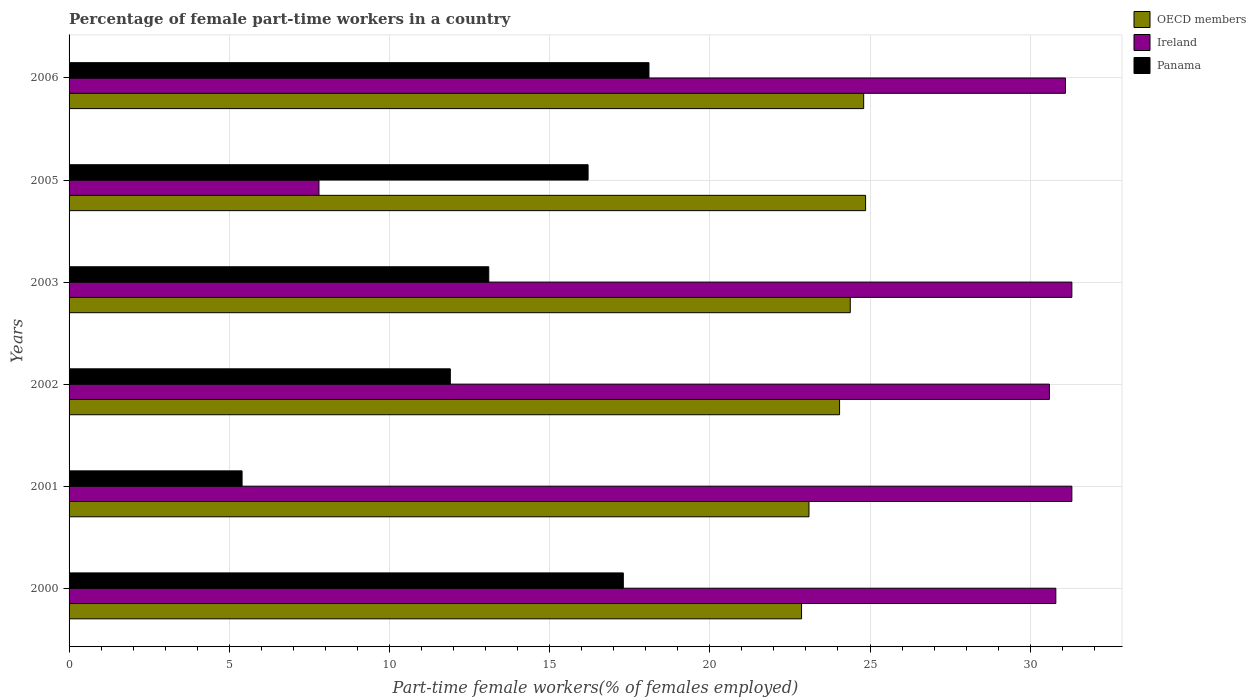How many different coloured bars are there?
Offer a very short reply. 3. Are the number of bars per tick equal to the number of legend labels?
Give a very brief answer. Yes. Are the number of bars on each tick of the Y-axis equal?
Give a very brief answer. Yes. How many bars are there on the 5th tick from the bottom?
Your answer should be compact. 3. In how many cases, is the number of bars for a given year not equal to the number of legend labels?
Offer a very short reply. 0. What is the percentage of female part-time workers in Panama in 2003?
Ensure brevity in your answer.  13.1. Across all years, what is the maximum percentage of female part-time workers in Ireland?
Offer a terse response. 31.3. Across all years, what is the minimum percentage of female part-time workers in Ireland?
Ensure brevity in your answer.  7.8. What is the total percentage of female part-time workers in Ireland in the graph?
Your answer should be compact. 162.9. What is the difference between the percentage of female part-time workers in Panama in 2005 and that in 2006?
Keep it short and to the point. -1.9. What is the difference between the percentage of female part-time workers in Panama in 2005 and the percentage of female part-time workers in OECD members in 2003?
Make the answer very short. -8.18. What is the average percentage of female part-time workers in Panama per year?
Ensure brevity in your answer.  13.67. What is the ratio of the percentage of female part-time workers in Ireland in 2005 to that in 2006?
Keep it short and to the point. 0.25. What is the difference between the highest and the second highest percentage of female part-time workers in OECD members?
Make the answer very short. 0.06. What is the difference between the highest and the lowest percentage of female part-time workers in Panama?
Ensure brevity in your answer.  12.7. What does the 1st bar from the top in 2006 represents?
Offer a terse response. Panama. How many bars are there?
Provide a short and direct response. 18. Are all the bars in the graph horizontal?
Your response must be concise. Yes. Are the values on the major ticks of X-axis written in scientific E-notation?
Offer a terse response. No. Does the graph contain any zero values?
Your response must be concise. No. Does the graph contain grids?
Offer a very short reply. Yes. Where does the legend appear in the graph?
Your response must be concise. Top right. How many legend labels are there?
Keep it short and to the point. 3. How are the legend labels stacked?
Keep it short and to the point. Vertical. What is the title of the graph?
Make the answer very short. Percentage of female part-time workers in a country. Does "Arab World" appear as one of the legend labels in the graph?
Your response must be concise. No. What is the label or title of the X-axis?
Give a very brief answer. Part-time female workers(% of females employed). What is the label or title of the Y-axis?
Give a very brief answer. Years. What is the Part-time female workers(% of females employed) of OECD members in 2000?
Ensure brevity in your answer.  22.86. What is the Part-time female workers(% of females employed) in Ireland in 2000?
Offer a terse response. 30.8. What is the Part-time female workers(% of females employed) of Panama in 2000?
Offer a very short reply. 17.3. What is the Part-time female workers(% of females employed) in OECD members in 2001?
Ensure brevity in your answer.  23.09. What is the Part-time female workers(% of females employed) of Ireland in 2001?
Offer a terse response. 31.3. What is the Part-time female workers(% of females employed) in Panama in 2001?
Give a very brief answer. 5.4. What is the Part-time female workers(% of females employed) in OECD members in 2002?
Offer a terse response. 24.05. What is the Part-time female workers(% of females employed) of Ireland in 2002?
Your answer should be compact. 30.6. What is the Part-time female workers(% of females employed) in Panama in 2002?
Provide a succinct answer. 11.9. What is the Part-time female workers(% of females employed) of OECD members in 2003?
Your answer should be compact. 24.38. What is the Part-time female workers(% of females employed) in Ireland in 2003?
Make the answer very short. 31.3. What is the Part-time female workers(% of females employed) of Panama in 2003?
Make the answer very short. 13.1. What is the Part-time female workers(% of females employed) in OECD members in 2005?
Offer a terse response. 24.86. What is the Part-time female workers(% of females employed) in Ireland in 2005?
Give a very brief answer. 7.8. What is the Part-time female workers(% of females employed) of Panama in 2005?
Your response must be concise. 16.2. What is the Part-time female workers(% of females employed) of OECD members in 2006?
Keep it short and to the point. 24.8. What is the Part-time female workers(% of females employed) of Ireland in 2006?
Give a very brief answer. 31.1. What is the Part-time female workers(% of females employed) in Panama in 2006?
Provide a succinct answer. 18.1. Across all years, what is the maximum Part-time female workers(% of females employed) of OECD members?
Your response must be concise. 24.86. Across all years, what is the maximum Part-time female workers(% of females employed) of Ireland?
Provide a short and direct response. 31.3. Across all years, what is the maximum Part-time female workers(% of females employed) of Panama?
Your response must be concise. 18.1. Across all years, what is the minimum Part-time female workers(% of females employed) in OECD members?
Keep it short and to the point. 22.86. Across all years, what is the minimum Part-time female workers(% of females employed) of Ireland?
Keep it short and to the point. 7.8. Across all years, what is the minimum Part-time female workers(% of females employed) in Panama?
Offer a terse response. 5.4. What is the total Part-time female workers(% of females employed) of OECD members in the graph?
Offer a terse response. 144.06. What is the total Part-time female workers(% of females employed) of Ireland in the graph?
Offer a very short reply. 162.9. What is the total Part-time female workers(% of females employed) in Panama in the graph?
Keep it short and to the point. 82. What is the difference between the Part-time female workers(% of females employed) of OECD members in 2000 and that in 2001?
Ensure brevity in your answer.  -0.23. What is the difference between the Part-time female workers(% of females employed) in Ireland in 2000 and that in 2001?
Your answer should be very brief. -0.5. What is the difference between the Part-time female workers(% of females employed) of Panama in 2000 and that in 2001?
Make the answer very short. 11.9. What is the difference between the Part-time female workers(% of females employed) of OECD members in 2000 and that in 2002?
Provide a short and direct response. -1.19. What is the difference between the Part-time female workers(% of females employed) in Ireland in 2000 and that in 2002?
Give a very brief answer. 0.2. What is the difference between the Part-time female workers(% of females employed) in Panama in 2000 and that in 2002?
Give a very brief answer. 5.4. What is the difference between the Part-time female workers(% of females employed) of OECD members in 2000 and that in 2003?
Ensure brevity in your answer.  -1.52. What is the difference between the Part-time female workers(% of females employed) in Ireland in 2000 and that in 2003?
Your answer should be very brief. -0.5. What is the difference between the Part-time female workers(% of females employed) in Panama in 2000 and that in 2003?
Make the answer very short. 4.2. What is the difference between the Part-time female workers(% of females employed) of OECD members in 2000 and that in 2005?
Ensure brevity in your answer.  -2. What is the difference between the Part-time female workers(% of females employed) in Panama in 2000 and that in 2005?
Offer a terse response. 1.1. What is the difference between the Part-time female workers(% of females employed) of OECD members in 2000 and that in 2006?
Your answer should be compact. -1.94. What is the difference between the Part-time female workers(% of females employed) in OECD members in 2001 and that in 2002?
Offer a very short reply. -0.96. What is the difference between the Part-time female workers(% of females employed) in OECD members in 2001 and that in 2003?
Your response must be concise. -1.29. What is the difference between the Part-time female workers(% of females employed) in Ireland in 2001 and that in 2003?
Ensure brevity in your answer.  0. What is the difference between the Part-time female workers(% of females employed) of Panama in 2001 and that in 2003?
Offer a terse response. -7.7. What is the difference between the Part-time female workers(% of females employed) in OECD members in 2001 and that in 2005?
Your answer should be compact. -1.77. What is the difference between the Part-time female workers(% of females employed) in OECD members in 2001 and that in 2006?
Your response must be concise. -1.71. What is the difference between the Part-time female workers(% of females employed) in Panama in 2002 and that in 2003?
Your answer should be very brief. -1.2. What is the difference between the Part-time female workers(% of females employed) of OECD members in 2002 and that in 2005?
Keep it short and to the point. -0.81. What is the difference between the Part-time female workers(% of females employed) of Ireland in 2002 and that in 2005?
Your answer should be compact. 22.8. What is the difference between the Part-time female workers(% of females employed) in OECD members in 2002 and that in 2006?
Offer a very short reply. -0.75. What is the difference between the Part-time female workers(% of females employed) of Ireland in 2002 and that in 2006?
Make the answer very short. -0.5. What is the difference between the Part-time female workers(% of females employed) in Panama in 2002 and that in 2006?
Provide a succinct answer. -6.2. What is the difference between the Part-time female workers(% of females employed) of OECD members in 2003 and that in 2005?
Provide a short and direct response. -0.48. What is the difference between the Part-time female workers(% of females employed) of Ireland in 2003 and that in 2005?
Your answer should be compact. 23.5. What is the difference between the Part-time female workers(% of females employed) of Panama in 2003 and that in 2005?
Offer a terse response. -3.1. What is the difference between the Part-time female workers(% of females employed) of OECD members in 2003 and that in 2006?
Offer a terse response. -0.42. What is the difference between the Part-time female workers(% of females employed) in Ireland in 2003 and that in 2006?
Ensure brevity in your answer.  0.2. What is the difference between the Part-time female workers(% of females employed) in OECD members in 2005 and that in 2006?
Provide a short and direct response. 0.06. What is the difference between the Part-time female workers(% of females employed) of Ireland in 2005 and that in 2006?
Your answer should be compact. -23.3. What is the difference between the Part-time female workers(% of females employed) of OECD members in 2000 and the Part-time female workers(% of females employed) of Ireland in 2001?
Your answer should be very brief. -8.44. What is the difference between the Part-time female workers(% of females employed) in OECD members in 2000 and the Part-time female workers(% of females employed) in Panama in 2001?
Your answer should be very brief. 17.46. What is the difference between the Part-time female workers(% of females employed) in Ireland in 2000 and the Part-time female workers(% of females employed) in Panama in 2001?
Provide a succinct answer. 25.4. What is the difference between the Part-time female workers(% of females employed) in OECD members in 2000 and the Part-time female workers(% of females employed) in Ireland in 2002?
Make the answer very short. -7.74. What is the difference between the Part-time female workers(% of females employed) of OECD members in 2000 and the Part-time female workers(% of females employed) of Panama in 2002?
Provide a short and direct response. 10.96. What is the difference between the Part-time female workers(% of females employed) of OECD members in 2000 and the Part-time female workers(% of females employed) of Ireland in 2003?
Give a very brief answer. -8.44. What is the difference between the Part-time female workers(% of females employed) of OECD members in 2000 and the Part-time female workers(% of females employed) of Panama in 2003?
Offer a very short reply. 9.76. What is the difference between the Part-time female workers(% of females employed) in Ireland in 2000 and the Part-time female workers(% of females employed) in Panama in 2003?
Offer a terse response. 17.7. What is the difference between the Part-time female workers(% of females employed) of OECD members in 2000 and the Part-time female workers(% of females employed) of Ireland in 2005?
Provide a succinct answer. 15.06. What is the difference between the Part-time female workers(% of females employed) of OECD members in 2000 and the Part-time female workers(% of females employed) of Panama in 2005?
Provide a short and direct response. 6.66. What is the difference between the Part-time female workers(% of females employed) of OECD members in 2000 and the Part-time female workers(% of females employed) of Ireland in 2006?
Offer a terse response. -8.24. What is the difference between the Part-time female workers(% of females employed) in OECD members in 2000 and the Part-time female workers(% of females employed) in Panama in 2006?
Provide a succinct answer. 4.76. What is the difference between the Part-time female workers(% of females employed) in OECD members in 2001 and the Part-time female workers(% of females employed) in Ireland in 2002?
Provide a succinct answer. -7.51. What is the difference between the Part-time female workers(% of females employed) in OECD members in 2001 and the Part-time female workers(% of females employed) in Panama in 2002?
Keep it short and to the point. 11.19. What is the difference between the Part-time female workers(% of females employed) of Ireland in 2001 and the Part-time female workers(% of females employed) of Panama in 2002?
Give a very brief answer. 19.4. What is the difference between the Part-time female workers(% of females employed) of OECD members in 2001 and the Part-time female workers(% of females employed) of Ireland in 2003?
Your answer should be compact. -8.21. What is the difference between the Part-time female workers(% of females employed) of OECD members in 2001 and the Part-time female workers(% of females employed) of Panama in 2003?
Provide a succinct answer. 9.99. What is the difference between the Part-time female workers(% of females employed) in Ireland in 2001 and the Part-time female workers(% of females employed) in Panama in 2003?
Keep it short and to the point. 18.2. What is the difference between the Part-time female workers(% of females employed) of OECD members in 2001 and the Part-time female workers(% of females employed) of Ireland in 2005?
Keep it short and to the point. 15.29. What is the difference between the Part-time female workers(% of females employed) in OECD members in 2001 and the Part-time female workers(% of females employed) in Panama in 2005?
Keep it short and to the point. 6.89. What is the difference between the Part-time female workers(% of females employed) of OECD members in 2001 and the Part-time female workers(% of females employed) of Ireland in 2006?
Your answer should be very brief. -8.01. What is the difference between the Part-time female workers(% of females employed) in OECD members in 2001 and the Part-time female workers(% of females employed) in Panama in 2006?
Keep it short and to the point. 4.99. What is the difference between the Part-time female workers(% of females employed) in OECD members in 2002 and the Part-time female workers(% of females employed) in Ireland in 2003?
Ensure brevity in your answer.  -7.25. What is the difference between the Part-time female workers(% of females employed) of OECD members in 2002 and the Part-time female workers(% of females employed) of Panama in 2003?
Provide a short and direct response. 10.95. What is the difference between the Part-time female workers(% of females employed) of OECD members in 2002 and the Part-time female workers(% of females employed) of Ireland in 2005?
Ensure brevity in your answer.  16.25. What is the difference between the Part-time female workers(% of females employed) of OECD members in 2002 and the Part-time female workers(% of females employed) of Panama in 2005?
Your answer should be very brief. 7.85. What is the difference between the Part-time female workers(% of females employed) of Ireland in 2002 and the Part-time female workers(% of females employed) of Panama in 2005?
Offer a terse response. 14.4. What is the difference between the Part-time female workers(% of females employed) of OECD members in 2002 and the Part-time female workers(% of females employed) of Ireland in 2006?
Your response must be concise. -7.05. What is the difference between the Part-time female workers(% of females employed) of OECD members in 2002 and the Part-time female workers(% of females employed) of Panama in 2006?
Offer a terse response. 5.95. What is the difference between the Part-time female workers(% of females employed) of OECD members in 2003 and the Part-time female workers(% of females employed) of Ireland in 2005?
Provide a short and direct response. 16.58. What is the difference between the Part-time female workers(% of females employed) of OECD members in 2003 and the Part-time female workers(% of females employed) of Panama in 2005?
Your answer should be compact. 8.18. What is the difference between the Part-time female workers(% of females employed) in OECD members in 2003 and the Part-time female workers(% of females employed) in Ireland in 2006?
Offer a terse response. -6.72. What is the difference between the Part-time female workers(% of females employed) of OECD members in 2003 and the Part-time female workers(% of females employed) of Panama in 2006?
Give a very brief answer. 6.28. What is the difference between the Part-time female workers(% of females employed) of OECD members in 2005 and the Part-time female workers(% of females employed) of Ireland in 2006?
Your response must be concise. -6.24. What is the difference between the Part-time female workers(% of females employed) in OECD members in 2005 and the Part-time female workers(% of females employed) in Panama in 2006?
Your answer should be very brief. 6.76. What is the average Part-time female workers(% of females employed) in OECD members per year?
Provide a succinct answer. 24.01. What is the average Part-time female workers(% of females employed) of Ireland per year?
Your answer should be compact. 27.15. What is the average Part-time female workers(% of females employed) in Panama per year?
Your answer should be very brief. 13.67. In the year 2000, what is the difference between the Part-time female workers(% of females employed) of OECD members and Part-time female workers(% of females employed) of Ireland?
Your answer should be very brief. -7.94. In the year 2000, what is the difference between the Part-time female workers(% of females employed) in OECD members and Part-time female workers(% of females employed) in Panama?
Your answer should be compact. 5.56. In the year 2000, what is the difference between the Part-time female workers(% of females employed) in Ireland and Part-time female workers(% of females employed) in Panama?
Your answer should be compact. 13.5. In the year 2001, what is the difference between the Part-time female workers(% of females employed) of OECD members and Part-time female workers(% of females employed) of Ireland?
Give a very brief answer. -8.21. In the year 2001, what is the difference between the Part-time female workers(% of females employed) in OECD members and Part-time female workers(% of females employed) in Panama?
Offer a terse response. 17.69. In the year 2001, what is the difference between the Part-time female workers(% of females employed) in Ireland and Part-time female workers(% of females employed) in Panama?
Your answer should be compact. 25.9. In the year 2002, what is the difference between the Part-time female workers(% of females employed) of OECD members and Part-time female workers(% of females employed) of Ireland?
Give a very brief answer. -6.55. In the year 2002, what is the difference between the Part-time female workers(% of females employed) in OECD members and Part-time female workers(% of females employed) in Panama?
Your answer should be very brief. 12.15. In the year 2002, what is the difference between the Part-time female workers(% of females employed) in Ireland and Part-time female workers(% of females employed) in Panama?
Give a very brief answer. 18.7. In the year 2003, what is the difference between the Part-time female workers(% of females employed) in OECD members and Part-time female workers(% of females employed) in Ireland?
Provide a short and direct response. -6.92. In the year 2003, what is the difference between the Part-time female workers(% of females employed) of OECD members and Part-time female workers(% of females employed) of Panama?
Make the answer very short. 11.28. In the year 2003, what is the difference between the Part-time female workers(% of females employed) of Ireland and Part-time female workers(% of females employed) of Panama?
Give a very brief answer. 18.2. In the year 2005, what is the difference between the Part-time female workers(% of females employed) of OECD members and Part-time female workers(% of females employed) of Ireland?
Give a very brief answer. 17.06. In the year 2005, what is the difference between the Part-time female workers(% of females employed) of OECD members and Part-time female workers(% of females employed) of Panama?
Your response must be concise. 8.66. In the year 2006, what is the difference between the Part-time female workers(% of females employed) in OECD members and Part-time female workers(% of females employed) in Ireland?
Ensure brevity in your answer.  -6.3. In the year 2006, what is the difference between the Part-time female workers(% of females employed) of OECD members and Part-time female workers(% of females employed) of Panama?
Offer a very short reply. 6.7. What is the ratio of the Part-time female workers(% of females employed) of Ireland in 2000 to that in 2001?
Offer a very short reply. 0.98. What is the ratio of the Part-time female workers(% of females employed) of Panama in 2000 to that in 2001?
Ensure brevity in your answer.  3.2. What is the ratio of the Part-time female workers(% of females employed) in OECD members in 2000 to that in 2002?
Provide a short and direct response. 0.95. What is the ratio of the Part-time female workers(% of females employed) in Ireland in 2000 to that in 2002?
Keep it short and to the point. 1.01. What is the ratio of the Part-time female workers(% of females employed) of Panama in 2000 to that in 2002?
Keep it short and to the point. 1.45. What is the ratio of the Part-time female workers(% of females employed) of OECD members in 2000 to that in 2003?
Your answer should be very brief. 0.94. What is the ratio of the Part-time female workers(% of females employed) in Ireland in 2000 to that in 2003?
Offer a terse response. 0.98. What is the ratio of the Part-time female workers(% of females employed) of Panama in 2000 to that in 2003?
Make the answer very short. 1.32. What is the ratio of the Part-time female workers(% of females employed) of OECD members in 2000 to that in 2005?
Provide a short and direct response. 0.92. What is the ratio of the Part-time female workers(% of females employed) of Ireland in 2000 to that in 2005?
Offer a very short reply. 3.95. What is the ratio of the Part-time female workers(% of females employed) of Panama in 2000 to that in 2005?
Provide a short and direct response. 1.07. What is the ratio of the Part-time female workers(% of females employed) in OECD members in 2000 to that in 2006?
Provide a short and direct response. 0.92. What is the ratio of the Part-time female workers(% of females employed) in Panama in 2000 to that in 2006?
Your response must be concise. 0.96. What is the ratio of the Part-time female workers(% of females employed) of OECD members in 2001 to that in 2002?
Your response must be concise. 0.96. What is the ratio of the Part-time female workers(% of females employed) of Ireland in 2001 to that in 2002?
Provide a short and direct response. 1.02. What is the ratio of the Part-time female workers(% of females employed) of Panama in 2001 to that in 2002?
Make the answer very short. 0.45. What is the ratio of the Part-time female workers(% of females employed) of OECD members in 2001 to that in 2003?
Make the answer very short. 0.95. What is the ratio of the Part-time female workers(% of females employed) of Ireland in 2001 to that in 2003?
Keep it short and to the point. 1. What is the ratio of the Part-time female workers(% of females employed) in Panama in 2001 to that in 2003?
Ensure brevity in your answer.  0.41. What is the ratio of the Part-time female workers(% of females employed) in OECD members in 2001 to that in 2005?
Your answer should be compact. 0.93. What is the ratio of the Part-time female workers(% of females employed) in Ireland in 2001 to that in 2005?
Give a very brief answer. 4.01. What is the ratio of the Part-time female workers(% of females employed) of OECD members in 2001 to that in 2006?
Offer a terse response. 0.93. What is the ratio of the Part-time female workers(% of females employed) of Ireland in 2001 to that in 2006?
Offer a very short reply. 1.01. What is the ratio of the Part-time female workers(% of females employed) of Panama in 2001 to that in 2006?
Provide a succinct answer. 0.3. What is the ratio of the Part-time female workers(% of females employed) in OECD members in 2002 to that in 2003?
Offer a terse response. 0.99. What is the ratio of the Part-time female workers(% of females employed) of Ireland in 2002 to that in 2003?
Your answer should be compact. 0.98. What is the ratio of the Part-time female workers(% of females employed) of Panama in 2002 to that in 2003?
Provide a succinct answer. 0.91. What is the ratio of the Part-time female workers(% of females employed) in OECD members in 2002 to that in 2005?
Offer a terse response. 0.97. What is the ratio of the Part-time female workers(% of females employed) of Ireland in 2002 to that in 2005?
Ensure brevity in your answer.  3.92. What is the ratio of the Part-time female workers(% of females employed) in Panama in 2002 to that in 2005?
Offer a terse response. 0.73. What is the ratio of the Part-time female workers(% of females employed) in OECD members in 2002 to that in 2006?
Provide a succinct answer. 0.97. What is the ratio of the Part-time female workers(% of females employed) in Ireland in 2002 to that in 2006?
Your answer should be very brief. 0.98. What is the ratio of the Part-time female workers(% of females employed) of Panama in 2002 to that in 2006?
Your answer should be compact. 0.66. What is the ratio of the Part-time female workers(% of females employed) in OECD members in 2003 to that in 2005?
Provide a succinct answer. 0.98. What is the ratio of the Part-time female workers(% of females employed) of Ireland in 2003 to that in 2005?
Ensure brevity in your answer.  4.01. What is the ratio of the Part-time female workers(% of females employed) in Panama in 2003 to that in 2005?
Your answer should be compact. 0.81. What is the ratio of the Part-time female workers(% of females employed) in OECD members in 2003 to that in 2006?
Give a very brief answer. 0.98. What is the ratio of the Part-time female workers(% of females employed) in Ireland in 2003 to that in 2006?
Your response must be concise. 1.01. What is the ratio of the Part-time female workers(% of females employed) of Panama in 2003 to that in 2006?
Make the answer very short. 0.72. What is the ratio of the Part-time female workers(% of females employed) of Ireland in 2005 to that in 2006?
Make the answer very short. 0.25. What is the ratio of the Part-time female workers(% of females employed) of Panama in 2005 to that in 2006?
Keep it short and to the point. 0.9. What is the difference between the highest and the second highest Part-time female workers(% of females employed) in OECD members?
Give a very brief answer. 0.06. What is the difference between the highest and the second highest Part-time female workers(% of females employed) of Ireland?
Offer a very short reply. 0. What is the difference between the highest and the lowest Part-time female workers(% of females employed) in OECD members?
Offer a very short reply. 2. What is the difference between the highest and the lowest Part-time female workers(% of females employed) of Ireland?
Provide a succinct answer. 23.5. What is the difference between the highest and the lowest Part-time female workers(% of females employed) of Panama?
Your response must be concise. 12.7. 